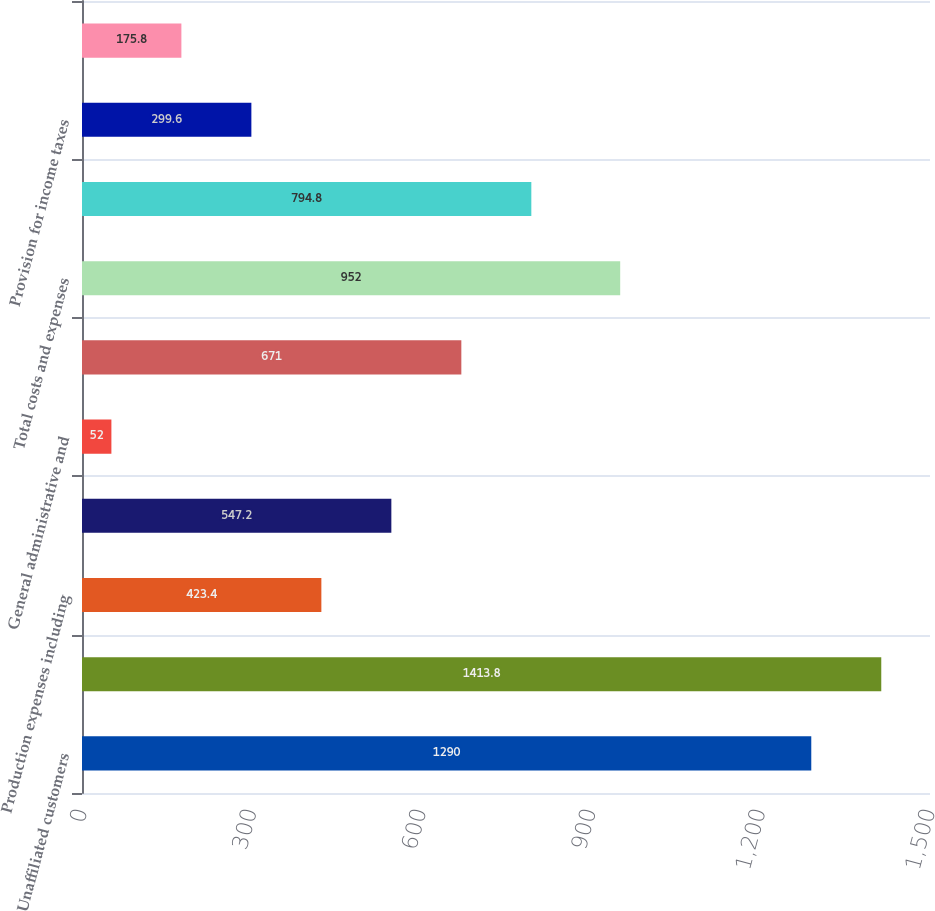Convert chart. <chart><loc_0><loc_0><loc_500><loc_500><bar_chart><fcel>Unaffiliated customers<fcel>Total revenues<fcel>Production expenses including<fcel>Exploration expenses including<fcel>General administrative and<fcel>Depreciation depletion and<fcel>Total costs and expenses<fcel>Results of operations before<fcel>Provision for income taxes<fcel>Results of operations<nl><fcel>1290<fcel>1413.8<fcel>423.4<fcel>547.2<fcel>52<fcel>671<fcel>952<fcel>794.8<fcel>299.6<fcel>175.8<nl></chart> 